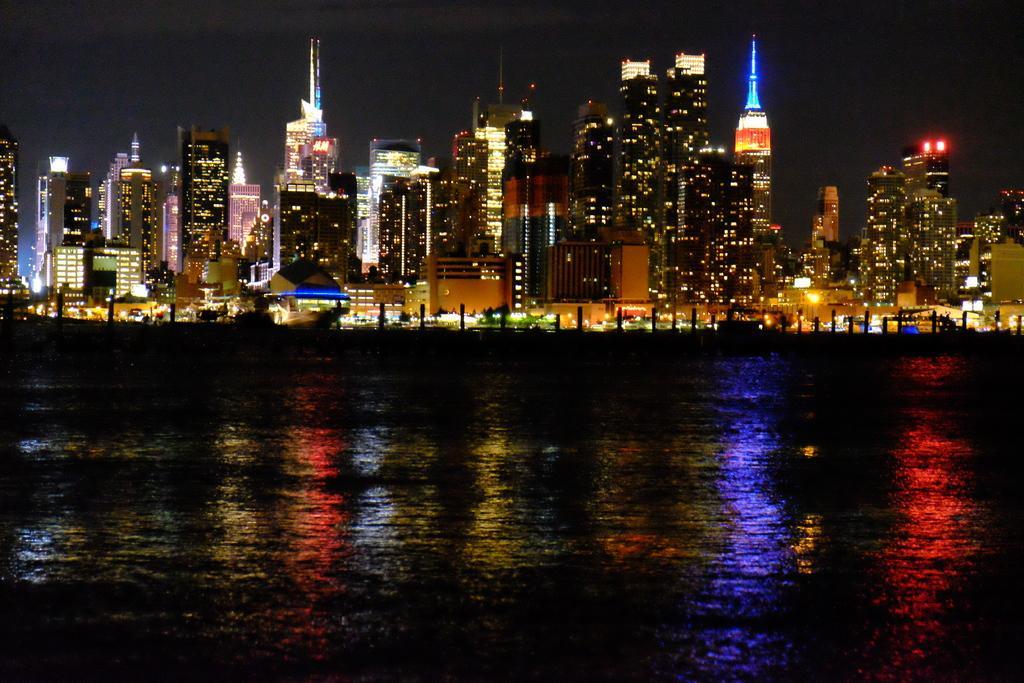How would you summarize this image in a sentence or two? In this picture we can see the night view of the buildings alongside the river. 